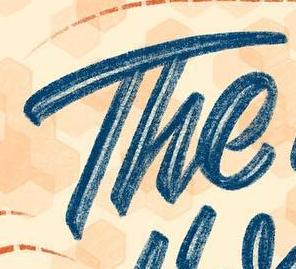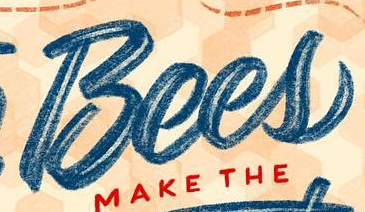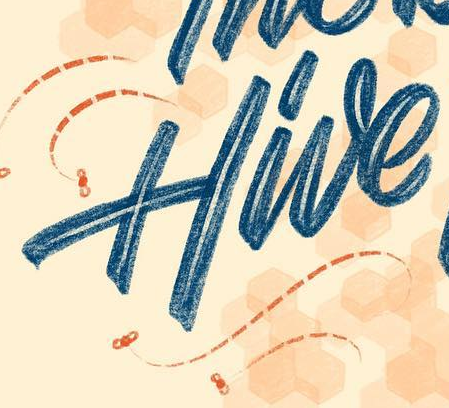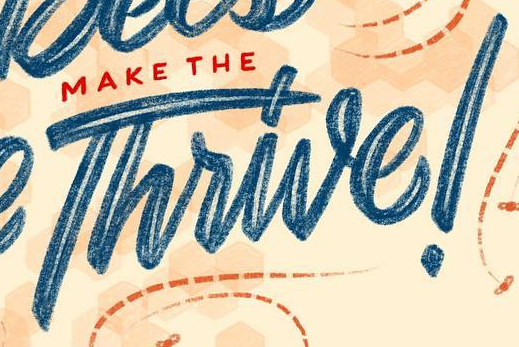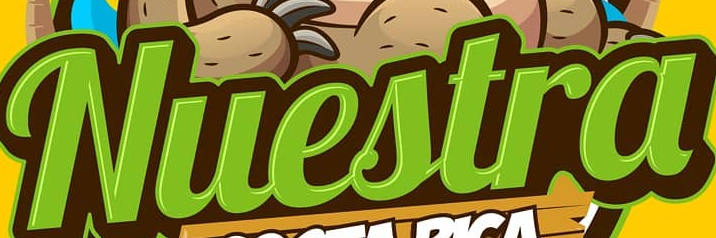Identify the words shown in these images in order, separated by a semicolon. The; Bees; Hive; Thrive!; Nuestra 